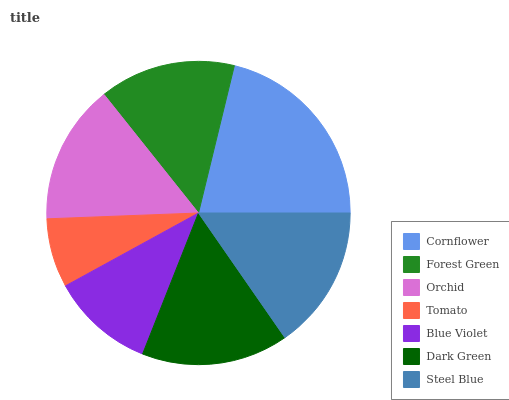Is Tomato the minimum?
Answer yes or no. Yes. Is Cornflower the maximum?
Answer yes or no. Yes. Is Forest Green the minimum?
Answer yes or no. No. Is Forest Green the maximum?
Answer yes or no. No. Is Cornflower greater than Forest Green?
Answer yes or no. Yes. Is Forest Green less than Cornflower?
Answer yes or no. Yes. Is Forest Green greater than Cornflower?
Answer yes or no. No. Is Cornflower less than Forest Green?
Answer yes or no. No. Is Orchid the high median?
Answer yes or no. Yes. Is Orchid the low median?
Answer yes or no. Yes. Is Blue Violet the high median?
Answer yes or no. No. Is Blue Violet the low median?
Answer yes or no. No. 